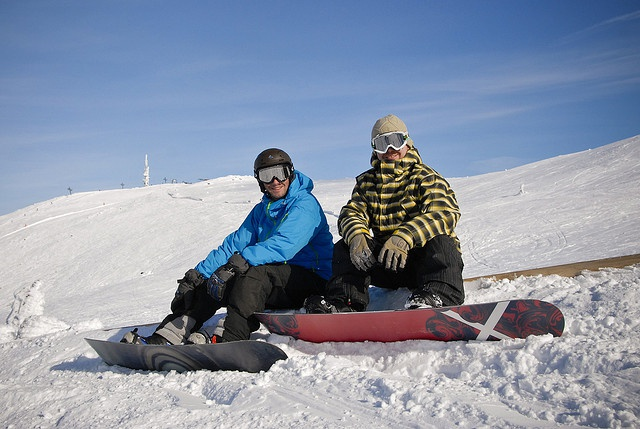Describe the objects in this image and their specific colors. I can see people in gray, black, lightblue, and navy tones, people in gray, black, olive, and tan tones, snowboard in gray, brown, maroon, and darkgray tones, snowboard in gray and black tones, and people in darkgray and gray tones in this image. 